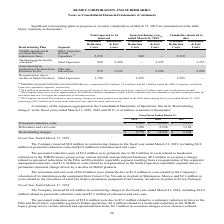From Kemet Corporation's financial document, Which years does the table provide information for expenses aggregated on the Consolidated Statements of Operations line item “Restructuring charges"? The document contains multiple relevant values: 2019, 2018, 2017. From the document: "2019 2018 2017 2019 2018 2017 2019 2018 2017..." Also, What were the relocation and exit costs in 2017? According to the financial document, 3,190 (in thousands). The relevant text states: "Relocation and exit costs 5,956 2,256 3,190..." Also, What were the restructuring charges in 2019? According to the financial document, 8,779 (in thousands). The relevant text states: "Restructuring charges $ 8,779 $ 14,843 $ 5,404..." Also, How many years did restructuring charges exceed $10,000 thousand? Based on the analysis, there are 1 instances. The counting process: 2018. Also, can you calculate: What was the change in Personnel reduction costs between 2017 and 2018? Based on the calculation: 12,587-2,214, the result is 10373 (in thousands). This is based on the information: "Personnel reduction costs $ 2,823 $ 12,587 $ 2,214 Personnel reduction costs $ 2,823 $ 12,587 $ 2,214..." The key data points involved are: 12,587, 2,214. Also, can you calculate: What was the percentage change in the Relocation and exit costs between 2018 and 2019? To answer this question, I need to perform calculations using the financial data. The calculation is: (5,956-2,256)/2,256, which equals 164.01 (percentage). This is based on the information: "Relocation and exit costs 5,956 2,256 3,190 Relocation and exit costs 5,956 2,256 3,190..." The key data points involved are: 2,256, 5,956. 